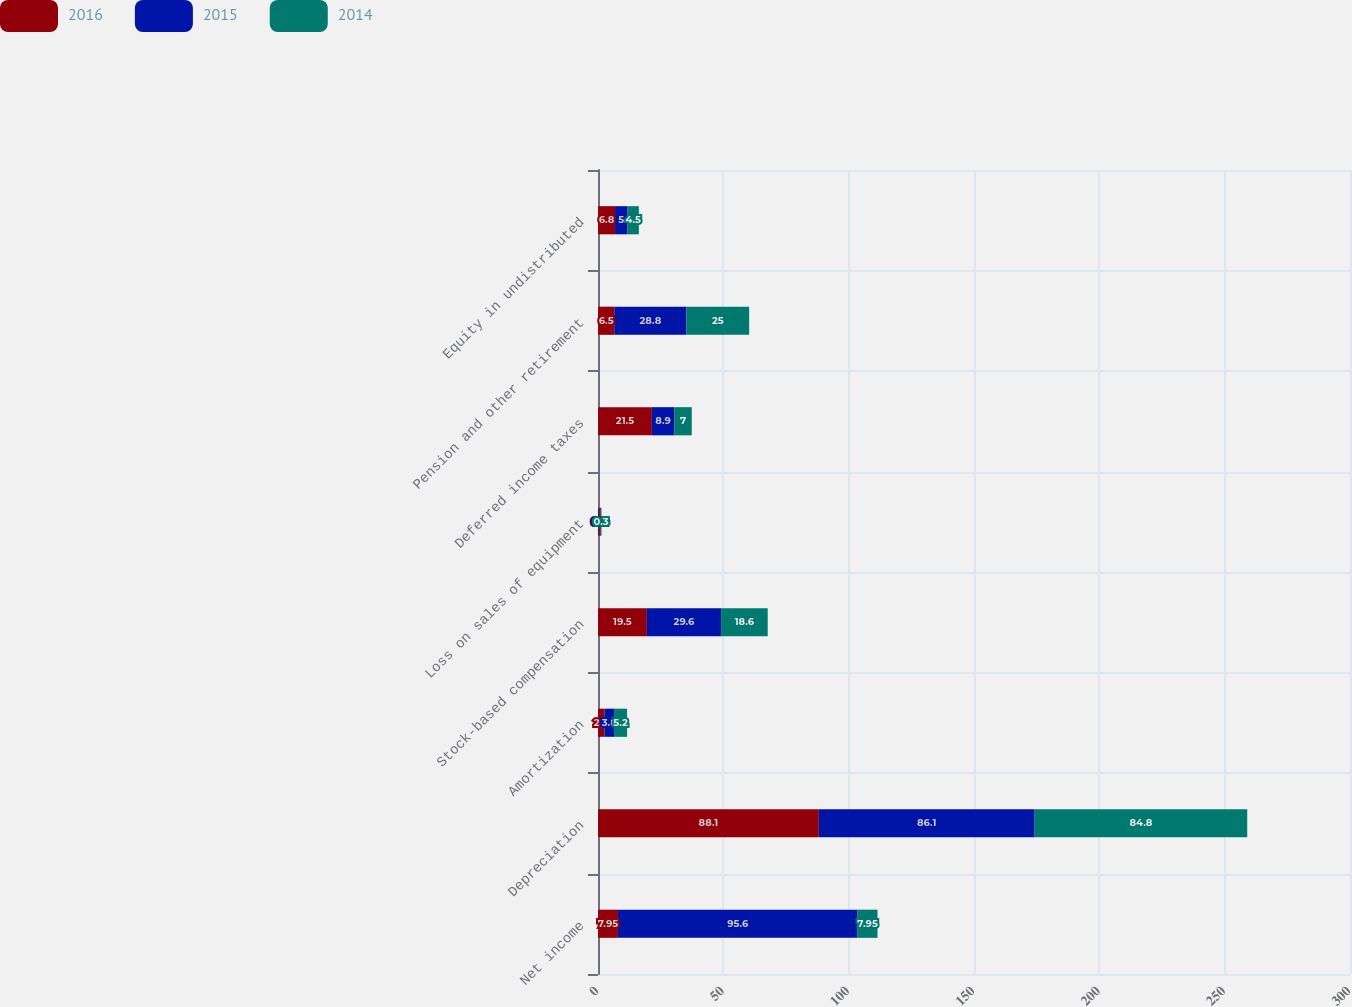Convert chart. <chart><loc_0><loc_0><loc_500><loc_500><stacked_bar_chart><ecel><fcel>Net income<fcel>Depreciation<fcel>Amortization<fcel>Stock-based compensation<fcel>Loss on sales of equipment<fcel>Deferred income taxes<fcel>Pension and other retirement<fcel>Equity in undistributed<nl><fcel>2016<fcel>7.95<fcel>88.1<fcel>2.6<fcel>19.5<fcel>0.7<fcel>21.5<fcel>6.5<fcel>6.8<nl><fcel>2015<fcel>95.6<fcel>86.1<fcel>3.8<fcel>29.6<fcel>0.4<fcel>8.9<fcel>28.8<fcel>5<nl><fcel>2014<fcel>7.95<fcel>84.8<fcel>5.2<fcel>18.6<fcel>0.3<fcel>7<fcel>25<fcel>4.5<nl></chart> 